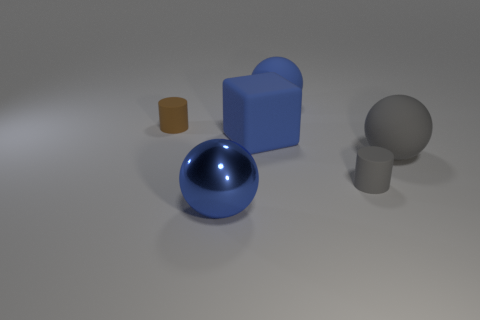Is the color of the shiny ball the same as the big matte block?
Keep it short and to the point. Yes. What number of things are large blue things that are behind the gray matte sphere or large blue balls in front of the tiny gray rubber cylinder?
Your response must be concise. 3. The thing that is in front of the matte block and behind the gray cylinder has what shape?
Make the answer very short. Sphere. There is a large ball in front of the tiny gray matte cylinder; what number of cylinders are left of it?
Ensure brevity in your answer.  1. How many things are either large blue balls in front of the gray cylinder or green spheres?
Provide a short and direct response. 1. There is a blue ball in front of the gray matte ball; what size is it?
Keep it short and to the point. Large. What is the material of the small brown object?
Give a very brief answer. Rubber. What is the shape of the large gray matte thing to the right of the cylinder that is in front of the big matte cube?
Offer a terse response. Sphere. What number of other things are there of the same shape as the shiny thing?
Offer a terse response. 2. There is a large blue matte block; are there any large things to the right of it?
Your answer should be very brief. Yes. 